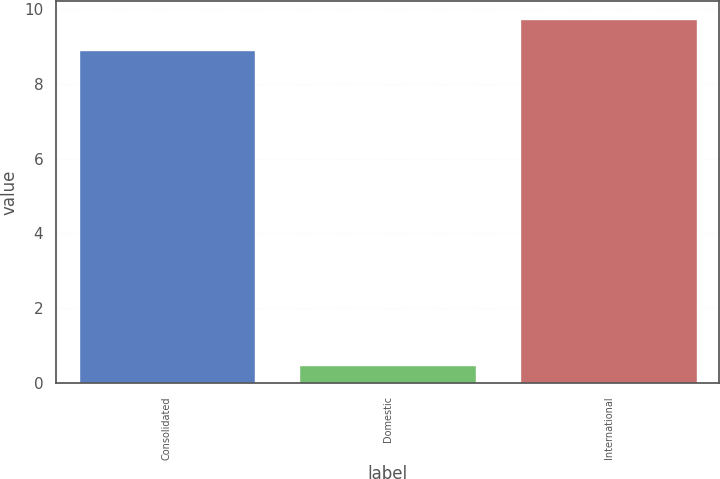Convert chart to OTSL. <chart><loc_0><loc_0><loc_500><loc_500><bar_chart><fcel>Consolidated<fcel>Domestic<fcel>International<nl><fcel>8.9<fcel>0.49<fcel>9.74<nl></chart> 